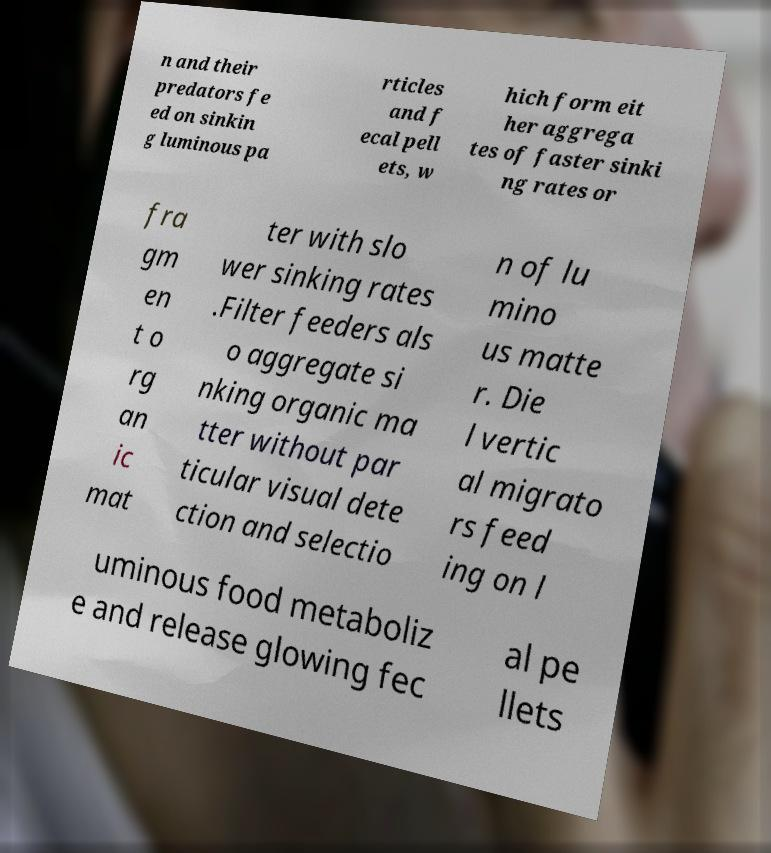I need the written content from this picture converted into text. Can you do that? n and their predators fe ed on sinkin g luminous pa rticles and f ecal pell ets, w hich form eit her aggrega tes of faster sinki ng rates or fra gm en t o rg an ic mat ter with slo wer sinking rates .Filter feeders als o aggregate si nking organic ma tter without par ticular visual dete ction and selectio n of lu mino us matte r. Die l vertic al migrato rs feed ing on l uminous food metaboliz e and release glowing fec al pe llets 